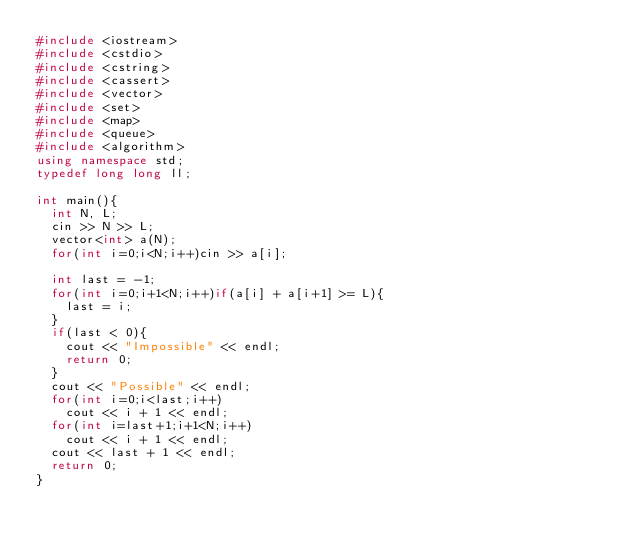<code> <loc_0><loc_0><loc_500><loc_500><_C++_>#include <iostream>
#include <cstdio>
#include <cstring>
#include <cassert>
#include <vector>
#include <set>
#include <map>
#include <queue>
#include <algorithm>
using namespace std;
typedef long long ll;

int main(){
  int N, L;
  cin >> N >> L;
  vector<int> a(N);
  for(int i=0;i<N;i++)cin >> a[i];

  int last = -1;
  for(int i=0;i+1<N;i++)if(a[i] + a[i+1] >= L){
    last = i;
  }
  if(last < 0){
    cout << "Impossible" << endl;
    return 0;
  }
  cout << "Possible" << endl;
  for(int i=0;i<last;i++)
    cout << i + 1 << endl;
  for(int i=last+1;i+1<N;i++)
    cout << i + 1 << endl;
  cout << last + 1 << endl;
  return 0;
}
</code> 